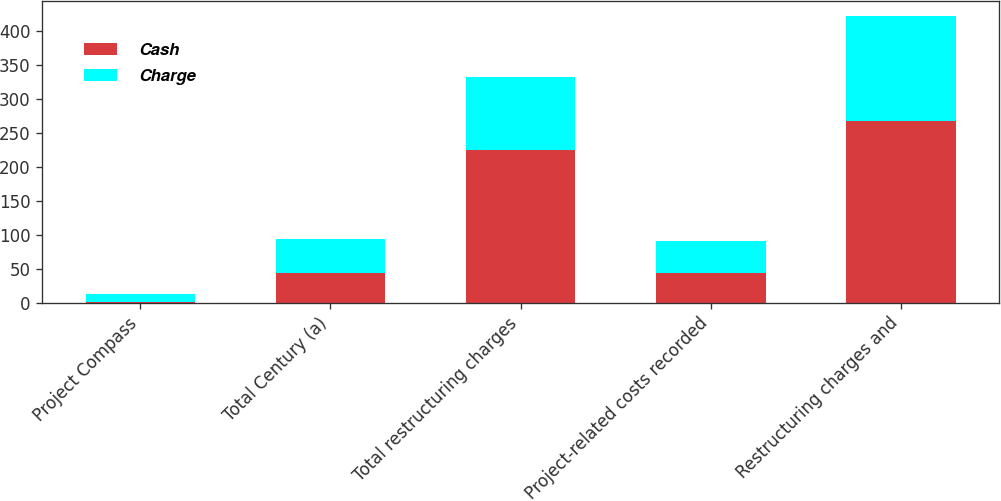Convert chart. <chart><loc_0><loc_0><loc_500><loc_500><stacked_bar_chart><ecel><fcel>Project Compass<fcel>Total Century (a)<fcel>Total restructuring charges<fcel>Project-related costs recorded<fcel>Restructuring charges and<nl><fcel>Cash<fcel>0.4<fcel>44<fcel>224.1<fcel>43.9<fcel>268<nl><fcel>Charge<fcel>12.8<fcel>49.4<fcel>107.8<fcel>46.9<fcel>154.7<nl></chart> 